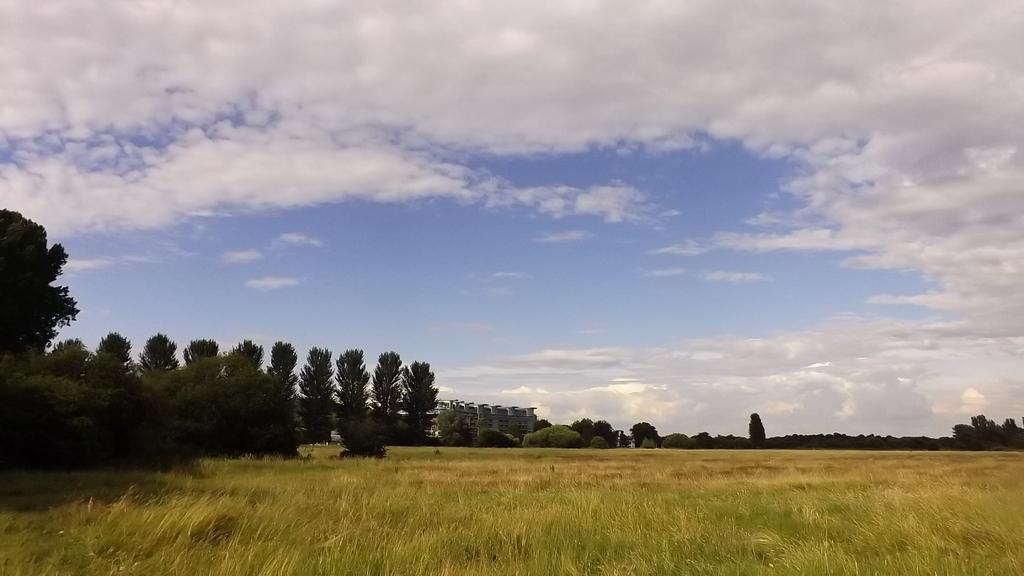What is located in the foreground of the image? There is a crop in the foreground of the image. What can be seen in the background of the image? There are trees and buildings in the background of the image. What is visible in the sky at the top of the image? There are clouds visible in the sky at the top of the image. What type of canvas is being used for education in the image? There is no canvas or reference to education present in the image. Can you introduce me to the friend in the image? There is no friend or person present in the image; it features a crop, trees, buildings, and clouds. 